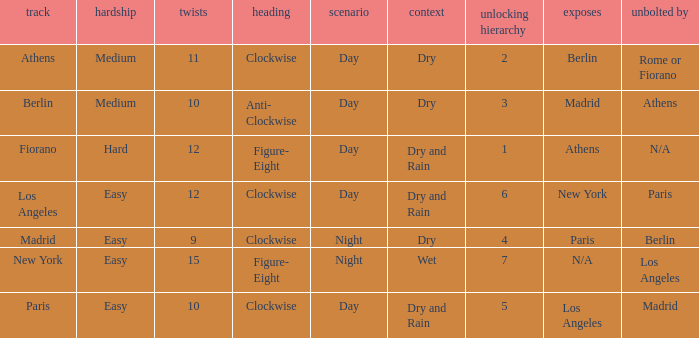How many instances is the unlocked n/a? 1.0. 